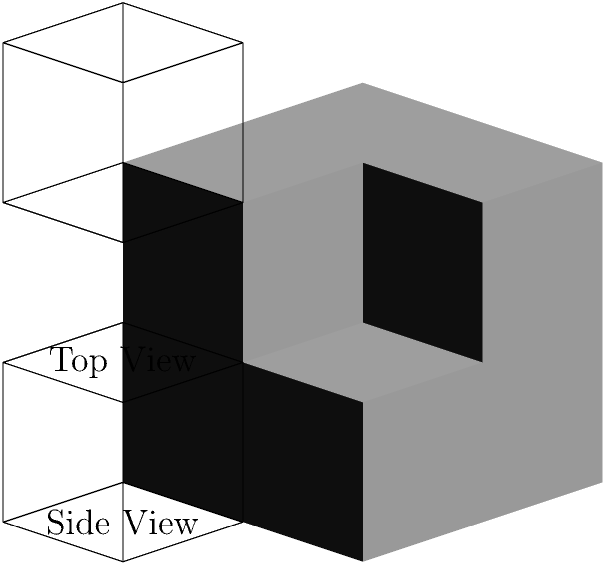As someone who has experienced brain lesions, you understand the importance of spatial reasoning in daily life. Looking at the 3D structure and its 2D views (front, top, and side), how many cubes are there in total? Let's approach this step-by-step:

1. Front view: We see a 2x2 square, indicating there are at least 4 cubes.

2. Top view: We see a 2x2 square, confirming the 2x2 base we saw in the front view.

3. Side view: We see a 2x1 rectangle, indicating that the structure is 2 cubes high in one column, but only 1 cube high in the other.

4. Combining this information:
   - The base layer has 2x2 = 4 cubes
   - The top layer has 2x1 = 2 cubes (covering only half of the base)

5. To verify, let's count the cubes in the 3D structure:
   - Bottom layer: 4 cubes
   - Top layer: 3 cubes (one seems to be missing in the back-right corner)

6. Total count: 4 (bottom) + 3 (top) = 7 cubes

This exercise demonstrates how we can use different perspectives to understand and analyze 3D structures, an important skill in spatial reasoning and daily activities.
Answer: 7 cubes 